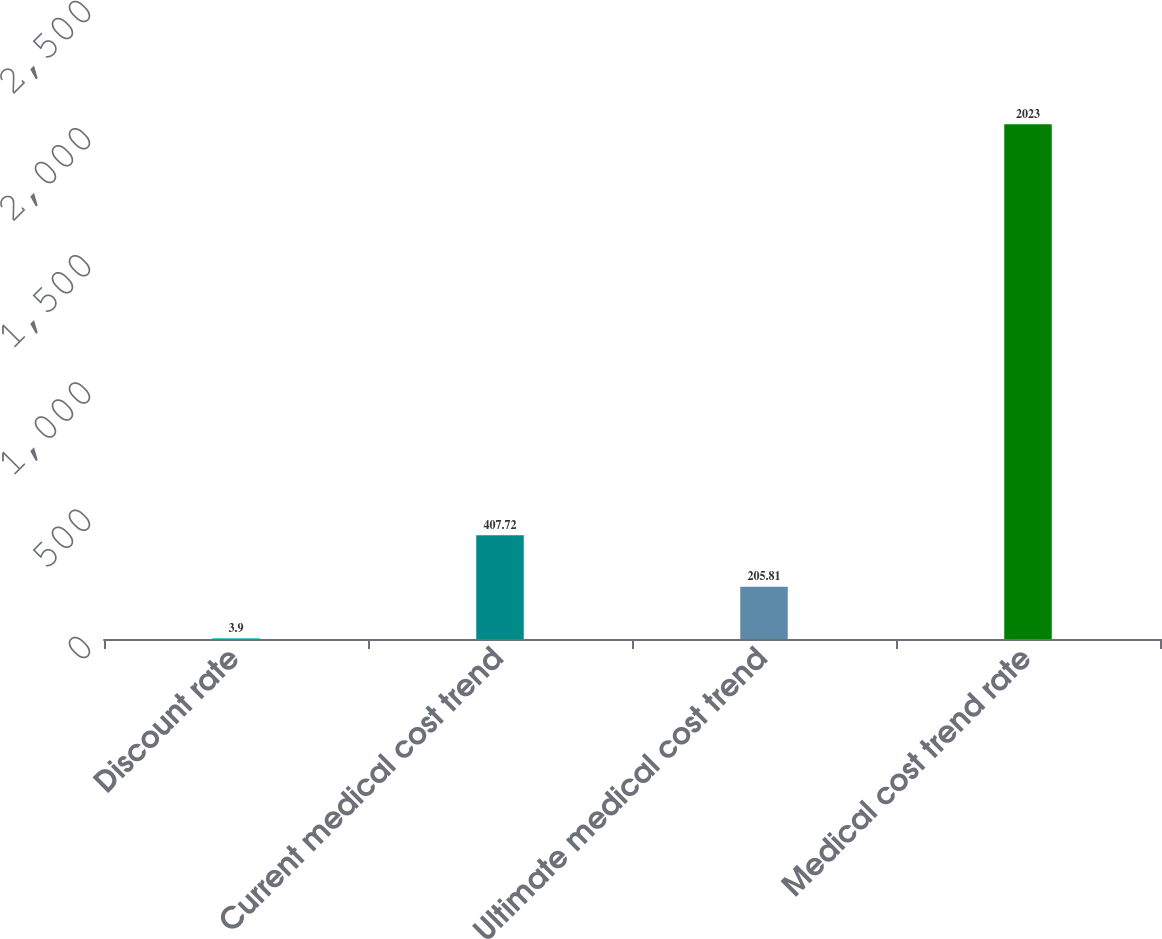<chart> <loc_0><loc_0><loc_500><loc_500><bar_chart><fcel>Discount rate<fcel>Current medical cost trend<fcel>Ultimate medical cost trend<fcel>Medical cost trend rate<nl><fcel>3.9<fcel>407.72<fcel>205.81<fcel>2023<nl></chart> 